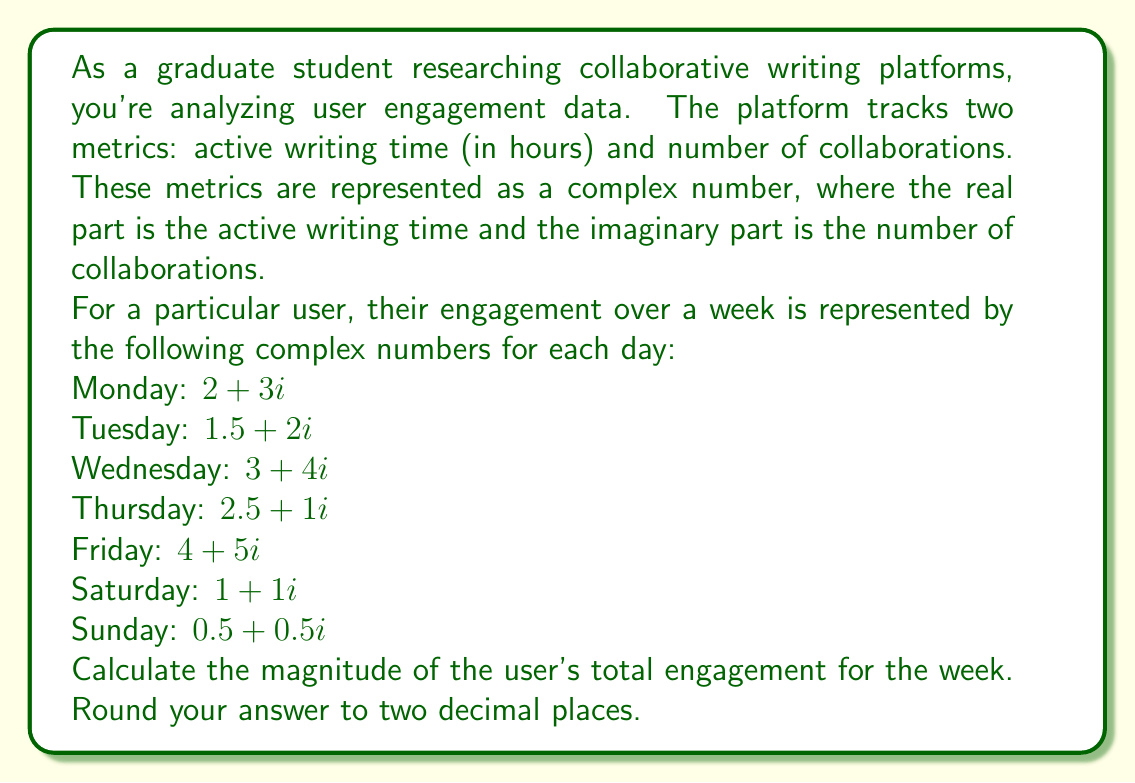Give your solution to this math problem. To solve this problem, we need to follow these steps:

1) First, we need to sum up all the complex numbers representing the user's engagement for each day of the week:

   $z = (2 + 3i) + (1.5 + 2i) + (3 + 4i) + (2.5 + 1i) + (4 + 5i) + (1 + 1i) + (0.5 + 0.5i)$

2) Simplify by adding the real and imaginary parts separately:

   $z = (2 + 1.5 + 3 + 2.5 + 4 + 1 + 0.5) + (3 + 2 + 4 + 1 + 5 + 1 + 0.5)i$
   $z = 14.5 + 16.5i$

3) Now, we need to calculate the magnitude of this complex number. The magnitude of a complex number $a + bi$ is given by the formula:

   $|a + bi| = \sqrt{a^2 + b^2}$

4) Substituting our values:

   $|14.5 + 16.5i| = \sqrt{14.5^2 + 16.5^2}$

5) Calculate:

   $|14.5 + 16.5i| = \sqrt{210.25 + 272.25}$
   $|14.5 + 16.5i| = \sqrt{482.5}$
   $|14.5 + 16.5i| \approx 21.9658$

6) Rounding to two decimal places:

   $|14.5 + 16.5i| \approx 21.97$

This final value represents the magnitude of the user's total engagement for the week, combining both active writing time and number of collaborations into a single metric.
Answer: $21.97$ 